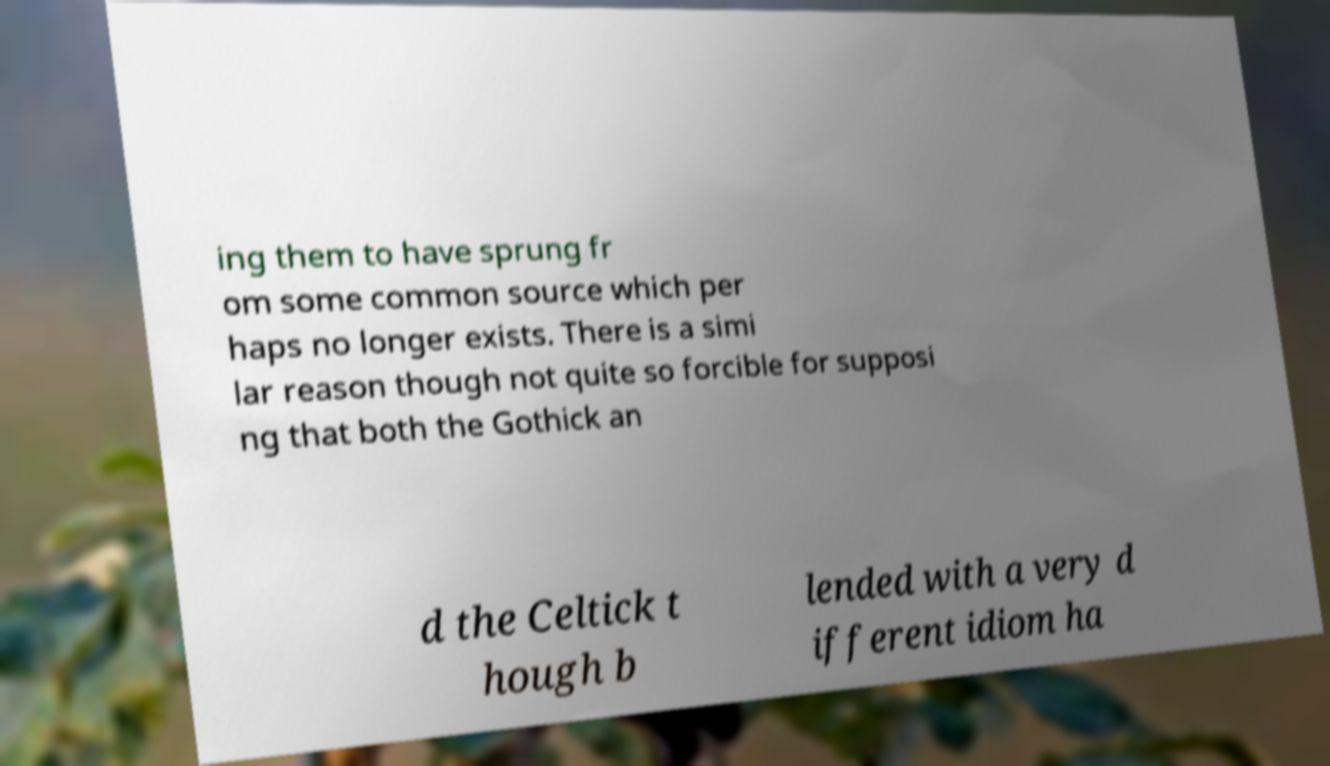I need the written content from this picture converted into text. Can you do that? ing them to have sprung fr om some common source which per haps no longer exists. There is a simi lar reason though not quite so forcible for supposi ng that both the Gothick an d the Celtick t hough b lended with a very d ifferent idiom ha 